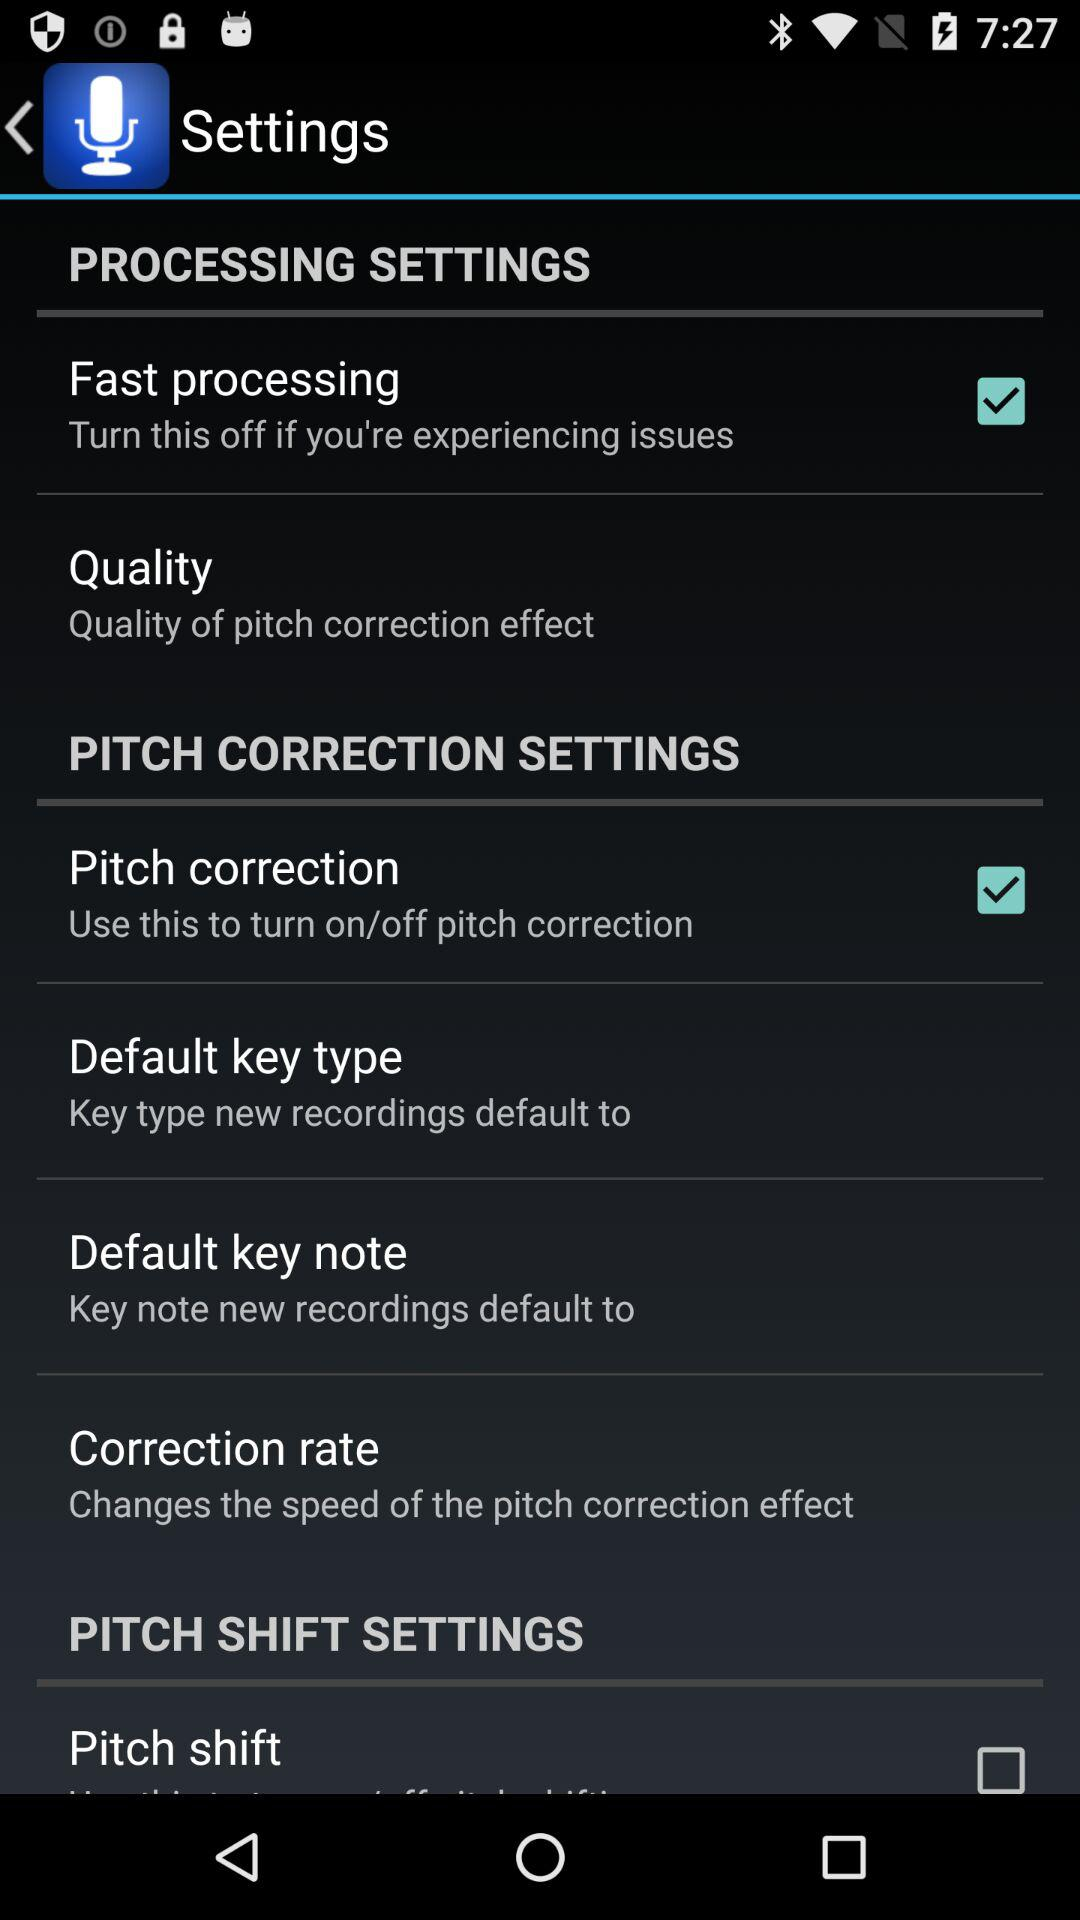What is the checked option in the processing settings? The checked option is "Fast processing". 